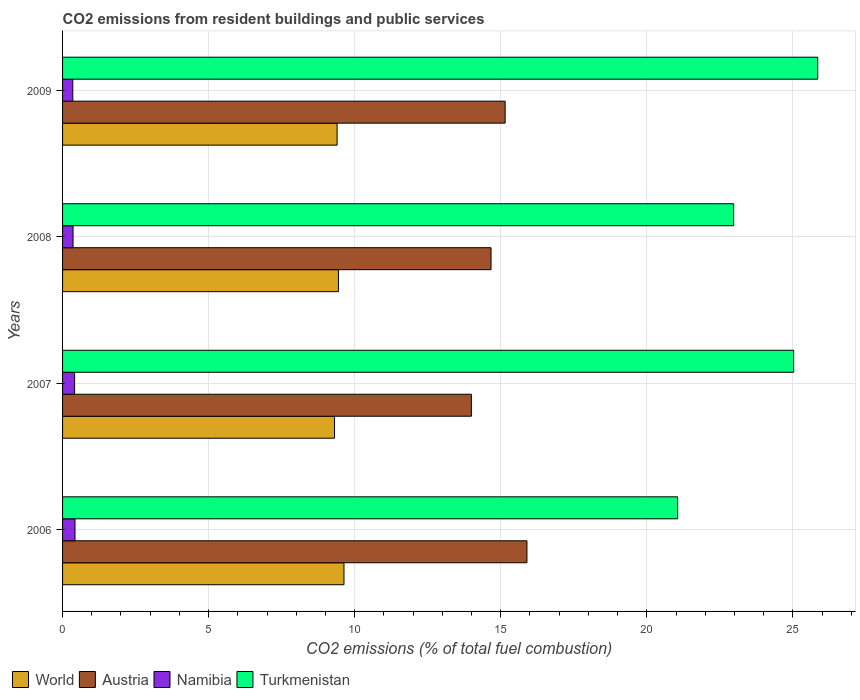How many different coloured bars are there?
Offer a very short reply. 4. How many groups of bars are there?
Your answer should be very brief. 4. Are the number of bars per tick equal to the number of legend labels?
Offer a very short reply. Yes. How many bars are there on the 4th tick from the bottom?
Offer a very short reply. 4. What is the label of the 1st group of bars from the top?
Offer a very short reply. 2009. In how many cases, is the number of bars for a given year not equal to the number of legend labels?
Keep it short and to the point. 0. What is the total CO2 emitted in Namibia in 2008?
Your answer should be very brief. 0.36. Across all years, what is the maximum total CO2 emitted in Turkmenistan?
Provide a succinct answer. 25.85. Across all years, what is the minimum total CO2 emitted in Austria?
Your answer should be very brief. 13.99. In which year was the total CO2 emitted in World minimum?
Offer a very short reply. 2007. What is the total total CO2 emitted in Turkmenistan in the graph?
Offer a very short reply. 94.91. What is the difference between the total CO2 emitted in Austria in 2007 and that in 2009?
Provide a succinct answer. -1.16. What is the difference between the total CO2 emitted in Turkmenistan in 2006 and the total CO2 emitted in Austria in 2009?
Give a very brief answer. 5.9. What is the average total CO2 emitted in Austria per year?
Offer a very short reply. 14.93. In the year 2006, what is the difference between the total CO2 emitted in Turkmenistan and total CO2 emitted in Namibia?
Offer a terse response. 20.63. In how many years, is the total CO2 emitted in World greater than 17 ?
Your answer should be compact. 0. What is the ratio of the total CO2 emitted in World in 2008 to that in 2009?
Make the answer very short. 1. Is the total CO2 emitted in World in 2006 less than that in 2008?
Your answer should be compact. No. Is the difference between the total CO2 emitted in Turkmenistan in 2006 and 2007 greater than the difference between the total CO2 emitted in Namibia in 2006 and 2007?
Your answer should be very brief. No. What is the difference between the highest and the second highest total CO2 emitted in World?
Ensure brevity in your answer.  0.19. What is the difference between the highest and the lowest total CO2 emitted in Namibia?
Keep it short and to the point. 0.08. Is the sum of the total CO2 emitted in Austria in 2006 and 2009 greater than the maximum total CO2 emitted in World across all years?
Provide a succinct answer. Yes. Is it the case that in every year, the sum of the total CO2 emitted in World and total CO2 emitted in Turkmenistan is greater than the sum of total CO2 emitted in Austria and total CO2 emitted in Namibia?
Make the answer very short. Yes. What does the 1st bar from the top in 2009 represents?
Offer a terse response. Turkmenistan. Is it the case that in every year, the sum of the total CO2 emitted in Turkmenistan and total CO2 emitted in Namibia is greater than the total CO2 emitted in World?
Keep it short and to the point. Yes. How many bars are there?
Your response must be concise. 16. Are all the bars in the graph horizontal?
Your answer should be very brief. Yes. How many years are there in the graph?
Your answer should be compact. 4. Does the graph contain any zero values?
Ensure brevity in your answer.  No. Where does the legend appear in the graph?
Your answer should be very brief. Bottom left. How many legend labels are there?
Provide a succinct answer. 4. How are the legend labels stacked?
Give a very brief answer. Horizontal. What is the title of the graph?
Offer a terse response. CO2 emissions from resident buildings and public services. Does "Uruguay" appear as one of the legend labels in the graph?
Make the answer very short. No. What is the label or title of the X-axis?
Ensure brevity in your answer.  CO2 emissions (% of total fuel combustion). What is the CO2 emissions (% of total fuel combustion) in World in 2006?
Your response must be concise. 9.63. What is the CO2 emissions (% of total fuel combustion) in Austria in 2006?
Your response must be concise. 15.9. What is the CO2 emissions (% of total fuel combustion) in Namibia in 2006?
Provide a succinct answer. 0.43. What is the CO2 emissions (% of total fuel combustion) of Turkmenistan in 2006?
Provide a succinct answer. 21.05. What is the CO2 emissions (% of total fuel combustion) in World in 2007?
Make the answer very short. 9.31. What is the CO2 emissions (% of total fuel combustion) in Austria in 2007?
Ensure brevity in your answer.  13.99. What is the CO2 emissions (% of total fuel combustion) in Namibia in 2007?
Your answer should be very brief. 0.41. What is the CO2 emissions (% of total fuel combustion) of Turkmenistan in 2007?
Offer a very short reply. 25.03. What is the CO2 emissions (% of total fuel combustion) of World in 2008?
Offer a very short reply. 9.44. What is the CO2 emissions (% of total fuel combustion) of Austria in 2008?
Provide a succinct answer. 14.67. What is the CO2 emissions (% of total fuel combustion) of Namibia in 2008?
Provide a succinct answer. 0.36. What is the CO2 emissions (% of total fuel combustion) of Turkmenistan in 2008?
Make the answer very short. 22.97. What is the CO2 emissions (% of total fuel combustion) of World in 2009?
Offer a terse response. 9.4. What is the CO2 emissions (% of total fuel combustion) in Austria in 2009?
Ensure brevity in your answer.  15.15. What is the CO2 emissions (% of total fuel combustion) of Namibia in 2009?
Provide a short and direct response. 0.35. What is the CO2 emissions (% of total fuel combustion) in Turkmenistan in 2009?
Your answer should be very brief. 25.85. Across all years, what is the maximum CO2 emissions (% of total fuel combustion) in World?
Provide a succinct answer. 9.63. Across all years, what is the maximum CO2 emissions (% of total fuel combustion) of Austria?
Ensure brevity in your answer.  15.9. Across all years, what is the maximum CO2 emissions (% of total fuel combustion) of Namibia?
Provide a short and direct response. 0.43. Across all years, what is the maximum CO2 emissions (% of total fuel combustion) of Turkmenistan?
Ensure brevity in your answer.  25.85. Across all years, what is the minimum CO2 emissions (% of total fuel combustion) in World?
Keep it short and to the point. 9.31. Across all years, what is the minimum CO2 emissions (% of total fuel combustion) in Austria?
Offer a very short reply. 13.99. Across all years, what is the minimum CO2 emissions (% of total fuel combustion) in Namibia?
Your answer should be compact. 0.35. Across all years, what is the minimum CO2 emissions (% of total fuel combustion) of Turkmenistan?
Keep it short and to the point. 21.05. What is the total CO2 emissions (% of total fuel combustion) of World in the graph?
Your answer should be very brief. 37.78. What is the total CO2 emissions (% of total fuel combustion) of Austria in the graph?
Provide a succinct answer. 59.71. What is the total CO2 emissions (% of total fuel combustion) in Namibia in the graph?
Provide a succinct answer. 1.55. What is the total CO2 emissions (% of total fuel combustion) of Turkmenistan in the graph?
Provide a succinct answer. 94.91. What is the difference between the CO2 emissions (% of total fuel combustion) in World in 2006 and that in 2007?
Offer a terse response. 0.32. What is the difference between the CO2 emissions (% of total fuel combustion) of Austria in 2006 and that in 2007?
Keep it short and to the point. 1.9. What is the difference between the CO2 emissions (% of total fuel combustion) in Namibia in 2006 and that in 2007?
Your response must be concise. 0.01. What is the difference between the CO2 emissions (% of total fuel combustion) in Turkmenistan in 2006 and that in 2007?
Your response must be concise. -3.97. What is the difference between the CO2 emissions (% of total fuel combustion) of World in 2006 and that in 2008?
Provide a short and direct response. 0.19. What is the difference between the CO2 emissions (% of total fuel combustion) of Austria in 2006 and that in 2008?
Give a very brief answer. 1.23. What is the difference between the CO2 emissions (% of total fuel combustion) in Namibia in 2006 and that in 2008?
Your response must be concise. 0.07. What is the difference between the CO2 emissions (% of total fuel combustion) in Turkmenistan in 2006 and that in 2008?
Offer a very short reply. -1.92. What is the difference between the CO2 emissions (% of total fuel combustion) in World in 2006 and that in 2009?
Offer a very short reply. 0.23. What is the difference between the CO2 emissions (% of total fuel combustion) in Austria in 2006 and that in 2009?
Offer a terse response. 0.75. What is the difference between the CO2 emissions (% of total fuel combustion) in Namibia in 2006 and that in 2009?
Keep it short and to the point. 0.08. What is the difference between the CO2 emissions (% of total fuel combustion) in Turkmenistan in 2006 and that in 2009?
Your answer should be very brief. -4.8. What is the difference between the CO2 emissions (% of total fuel combustion) in World in 2007 and that in 2008?
Make the answer very short. -0.13. What is the difference between the CO2 emissions (% of total fuel combustion) in Austria in 2007 and that in 2008?
Offer a very short reply. -0.67. What is the difference between the CO2 emissions (% of total fuel combustion) in Namibia in 2007 and that in 2008?
Ensure brevity in your answer.  0.05. What is the difference between the CO2 emissions (% of total fuel combustion) of Turkmenistan in 2007 and that in 2008?
Your answer should be compact. 2.05. What is the difference between the CO2 emissions (% of total fuel combustion) in World in 2007 and that in 2009?
Ensure brevity in your answer.  -0.09. What is the difference between the CO2 emissions (% of total fuel combustion) in Austria in 2007 and that in 2009?
Give a very brief answer. -1.16. What is the difference between the CO2 emissions (% of total fuel combustion) of Namibia in 2007 and that in 2009?
Provide a short and direct response. 0.06. What is the difference between the CO2 emissions (% of total fuel combustion) of Turkmenistan in 2007 and that in 2009?
Provide a succinct answer. -0.82. What is the difference between the CO2 emissions (% of total fuel combustion) in World in 2008 and that in 2009?
Your response must be concise. 0.05. What is the difference between the CO2 emissions (% of total fuel combustion) in Austria in 2008 and that in 2009?
Your answer should be compact. -0.48. What is the difference between the CO2 emissions (% of total fuel combustion) of Namibia in 2008 and that in 2009?
Offer a very short reply. 0.01. What is the difference between the CO2 emissions (% of total fuel combustion) in Turkmenistan in 2008 and that in 2009?
Provide a short and direct response. -2.88. What is the difference between the CO2 emissions (% of total fuel combustion) in World in 2006 and the CO2 emissions (% of total fuel combustion) in Austria in 2007?
Provide a short and direct response. -4.36. What is the difference between the CO2 emissions (% of total fuel combustion) in World in 2006 and the CO2 emissions (% of total fuel combustion) in Namibia in 2007?
Offer a terse response. 9.22. What is the difference between the CO2 emissions (% of total fuel combustion) in World in 2006 and the CO2 emissions (% of total fuel combustion) in Turkmenistan in 2007?
Your answer should be compact. -15.39. What is the difference between the CO2 emissions (% of total fuel combustion) in Austria in 2006 and the CO2 emissions (% of total fuel combustion) in Namibia in 2007?
Make the answer very short. 15.48. What is the difference between the CO2 emissions (% of total fuel combustion) in Austria in 2006 and the CO2 emissions (% of total fuel combustion) in Turkmenistan in 2007?
Provide a succinct answer. -9.13. What is the difference between the CO2 emissions (% of total fuel combustion) of Namibia in 2006 and the CO2 emissions (% of total fuel combustion) of Turkmenistan in 2007?
Keep it short and to the point. -24.6. What is the difference between the CO2 emissions (% of total fuel combustion) in World in 2006 and the CO2 emissions (% of total fuel combustion) in Austria in 2008?
Offer a terse response. -5.03. What is the difference between the CO2 emissions (% of total fuel combustion) of World in 2006 and the CO2 emissions (% of total fuel combustion) of Namibia in 2008?
Offer a terse response. 9.27. What is the difference between the CO2 emissions (% of total fuel combustion) in World in 2006 and the CO2 emissions (% of total fuel combustion) in Turkmenistan in 2008?
Your answer should be compact. -13.34. What is the difference between the CO2 emissions (% of total fuel combustion) of Austria in 2006 and the CO2 emissions (% of total fuel combustion) of Namibia in 2008?
Give a very brief answer. 15.54. What is the difference between the CO2 emissions (% of total fuel combustion) in Austria in 2006 and the CO2 emissions (% of total fuel combustion) in Turkmenistan in 2008?
Your answer should be compact. -7.08. What is the difference between the CO2 emissions (% of total fuel combustion) of Namibia in 2006 and the CO2 emissions (% of total fuel combustion) of Turkmenistan in 2008?
Offer a terse response. -22.55. What is the difference between the CO2 emissions (% of total fuel combustion) of World in 2006 and the CO2 emissions (% of total fuel combustion) of Austria in 2009?
Keep it short and to the point. -5.52. What is the difference between the CO2 emissions (% of total fuel combustion) in World in 2006 and the CO2 emissions (% of total fuel combustion) in Namibia in 2009?
Your answer should be compact. 9.28. What is the difference between the CO2 emissions (% of total fuel combustion) in World in 2006 and the CO2 emissions (% of total fuel combustion) in Turkmenistan in 2009?
Offer a terse response. -16.22. What is the difference between the CO2 emissions (% of total fuel combustion) in Austria in 2006 and the CO2 emissions (% of total fuel combustion) in Namibia in 2009?
Provide a short and direct response. 15.55. What is the difference between the CO2 emissions (% of total fuel combustion) of Austria in 2006 and the CO2 emissions (% of total fuel combustion) of Turkmenistan in 2009?
Your answer should be very brief. -9.95. What is the difference between the CO2 emissions (% of total fuel combustion) of Namibia in 2006 and the CO2 emissions (% of total fuel combustion) of Turkmenistan in 2009?
Keep it short and to the point. -25.43. What is the difference between the CO2 emissions (% of total fuel combustion) of World in 2007 and the CO2 emissions (% of total fuel combustion) of Austria in 2008?
Offer a terse response. -5.36. What is the difference between the CO2 emissions (% of total fuel combustion) in World in 2007 and the CO2 emissions (% of total fuel combustion) in Namibia in 2008?
Provide a short and direct response. 8.95. What is the difference between the CO2 emissions (% of total fuel combustion) of World in 2007 and the CO2 emissions (% of total fuel combustion) of Turkmenistan in 2008?
Make the answer very short. -13.66. What is the difference between the CO2 emissions (% of total fuel combustion) of Austria in 2007 and the CO2 emissions (% of total fuel combustion) of Namibia in 2008?
Offer a very short reply. 13.64. What is the difference between the CO2 emissions (% of total fuel combustion) of Austria in 2007 and the CO2 emissions (% of total fuel combustion) of Turkmenistan in 2008?
Ensure brevity in your answer.  -8.98. What is the difference between the CO2 emissions (% of total fuel combustion) of Namibia in 2007 and the CO2 emissions (% of total fuel combustion) of Turkmenistan in 2008?
Your response must be concise. -22.56. What is the difference between the CO2 emissions (% of total fuel combustion) in World in 2007 and the CO2 emissions (% of total fuel combustion) in Austria in 2009?
Ensure brevity in your answer.  -5.84. What is the difference between the CO2 emissions (% of total fuel combustion) in World in 2007 and the CO2 emissions (% of total fuel combustion) in Namibia in 2009?
Your response must be concise. 8.96. What is the difference between the CO2 emissions (% of total fuel combustion) in World in 2007 and the CO2 emissions (% of total fuel combustion) in Turkmenistan in 2009?
Give a very brief answer. -16.54. What is the difference between the CO2 emissions (% of total fuel combustion) in Austria in 2007 and the CO2 emissions (% of total fuel combustion) in Namibia in 2009?
Keep it short and to the point. 13.64. What is the difference between the CO2 emissions (% of total fuel combustion) in Austria in 2007 and the CO2 emissions (% of total fuel combustion) in Turkmenistan in 2009?
Provide a short and direct response. -11.86. What is the difference between the CO2 emissions (% of total fuel combustion) of Namibia in 2007 and the CO2 emissions (% of total fuel combustion) of Turkmenistan in 2009?
Give a very brief answer. -25.44. What is the difference between the CO2 emissions (% of total fuel combustion) in World in 2008 and the CO2 emissions (% of total fuel combustion) in Austria in 2009?
Keep it short and to the point. -5.71. What is the difference between the CO2 emissions (% of total fuel combustion) of World in 2008 and the CO2 emissions (% of total fuel combustion) of Namibia in 2009?
Your response must be concise. 9.09. What is the difference between the CO2 emissions (% of total fuel combustion) in World in 2008 and the CO2 emissions (% of total fuel combustion) in Turkmenistan in 2009?
Your answer should be very brief. -16.41. What is the difference between the CO2 emissions (% of total fuel combustion) in Austria in 2008 and the CO2 emissions (% of total fuel combustion) in Namibia in 2009?
Ensure brevity in your answer.  14.32. What is the difference between the CO2 emissions (% of total fuel combustion) of Austria in 2008 and the CO2 emissions (% of total fuel combustion) of Turkmenistan in 2009?
Your response must be concise. -11.18. What is the difference between the CO2 emissions (% of total fuel combustion) of Namibia in 2008 and the CO2 emissions (% of total fuel combustion) of Turkmenistan in 2009?
Offer a very short reply. -25.49. What is the average CO2 emissions (% of total fuel combustion) of World per year?
Your answer should be very brief. 9.45. What is the average CO2 emissions (% of total fuel combustion) in Austria per year?
Your answer should be compact. 14.93. What is the average CO2 emissions (% of total fuel combustion) in Namibia per year?
Give a very brief answer. 0.39. What is the average CO2 emissions (% of total fuel combustion) in Turkmenistan per year?
Your response must be concise. 23.73. In the year 2006, what is the difference between the CO2 emissions (% of total fuel combustion) of World and CO2 emissions (% of total fuel combustion) of Austria?
Give a very brief answer. -6.26. In the year 2006, what is the difference between the CO2 emissions (% of total fuel combustion) of World and CO2 emissions (% of total fuel combustion) of Namibia?
Your answer should be very brief. 9.21. In the year 2006, what is the difference between the CO2 emissions (% of total fuel combustion) in World and CO2 emissions (% of total fuel combustion) in Turkmenistan?
Provide a short and direct response. -11.42. In the year 2006, what is the difference between the CO2 emissions (% of total fuel combustion) in Austria and CO2 emissions (% of total fuel combustion) in Namibia?
Offer a terse response. 15.47. In the year 2006, what is the difference between the CO2 emissions (% of total fuel combustion) in Austria and CO2 emissions (% of total fuel combustion) in Turkmenistan?
Keep it short and to the point. -5.16. In the year 2006, what is the difference between the CO2 emissions (% of total fuel combustion) of Namibia and CO2 emissions (% of total fuel combustion) of Turkmenistan?
Provide a short and direct response. -20.63. In the year 2007, what is the difference between the CO2 emissions (% of total fuel combustion) in World and CO2 emissions (% of total fuel combustion) in Austria?
Your answer should be compact. -4.68. In the year 2007, what is the difference between the CO2 emissions (% of total fuel combustion) in World and CO2 emissions (% of total fuel combustion) in Namibia?
Ensure brevity in your answer.  8.9. In the year 2007, what is the difference between the CO2 emissions (% of total fuel combustion) in World and CO2 emissions (% of total fuel combustion) in Turkmenistan?
Provide a short and direct response. -15.72. In the year 2007, what is the difference between the CO2 emissions (% of total fuel combustion) in Austria and CO2 emissions (% of total fuel combustion) in Namibia?
Provide a succinct answer. 13.58. In the year 2007, what is the difference between the CO2 emissions (% of total fuel combustion) of Austria and CO2 emissions (% of total fuel combustion) of Turkmenistan?
Give a very brief answer. -11.03. In the year 2007, what is the difference between the CO2 emissions (% of total fuel combustion) in Namibia and CO2 emissions (% of total fuel combustion) in Turkmenistan?
Offer a very short reply. -24.62. In the year 2008, what is the difference between the CO2 emissions (% of total fuel combustion) of World and CO2 emissions (% of total fuel combustion) of Austria?
Keep it short and to the point. -5.22. In the year 2008, what is the difference between the CO2 emissions (% of total fuel combustion) in World and CO2 emissions (% of total fuel combustion) in Namibia?
Make the answer very short. 9.08. In the year 2008, what is the difference between the CO2 emissions (% of total fuel combustion) in World and CO2 emissions (% of total fuel combustion) in Turkmenistan?
Your answer should be very brief. -13.53. In the year 2008, what is the difference between the CO2 emissions (% of total fuel combustion) in Austria and CO2 emissions (% of total fuel combustion) in Namibia?
Provide a succinct answer. 14.31. In the year 2008, what is the difference between the CO2 emissions (% of total fuel combustion) in Austria and CO2 emissions (% of total fuel combustion) in Turkmenistan?
Provide a short and direct response. -8.31. In the year 2008, what is the difference between the CO2 emissions (% of total fuel combustion) in Namibia and CO2 emissions (% of total fuel combustion) in Turkmenistan?
Keep it short and to the point. -22.61. In the year 2009, what is the difference between the CO2 emissions (% of total fuel combustion) in World and CO2 emissions (% of total fuel combustion) in Austria?
Ensure brevity in your answer.  -5.75. In the year 2009, what is the difference between the CO2 emissions (% of total fuel combustion) in World and CO2 emissions (% of total fuel combustion) in Namibia?
Your answer should be compact. 9.05. In the year 2009, what is the difference between the CO2 emissions (% of total fuel combustion) in World and CO2 emissions (% of total fuel combustion) in Turkmenistan?
Give a very brief answer. -16.45. In the year 2009, what is the difference between the CO2 emissions (% of total fuel combustion) in Austria and CO2 emissions (% of total fuel combustion) in Namibia?
Offer a terse response. 14.8. In the year 2009, what is the difference between the CO2 emissions (% of total fuel combustion) in Austria and CO2 emissions (% of total fuel combustion) in Turkmenistan?
Offer a terse response. -10.7. In the year 2009, what is the difference between the CO2 emissions (% of total fuel combustion) of Namibia and CO2 emissions (% of total fuel combustion) of Turkmenistan?
Keep it short and to the point. -25.5. What is the ratio of the CO2 emissions (% of total fuel combustion) of World in 2006 to that in 2007?
Provide a short and direct response. 1.03. What is the ratio of the CO2 emissions (% of total fuel combustion) of Austria in 2006 to that in 2007?
Offer a terse response. 1.14. What is the ratio of the CO2 emissions (% of total fuel combustion) in Namibia in 2006 to that in 2007?
Give a very brief answer. 1.03. What is the ratio of the CO2 emissions (% of total fuel combustion) in Turkmenistan in 2006 to that in 2007?
Your answer should be very brief. 0.84. What is the ratio of the CO2 emissions (% of total fuel combustion) in World in 2006 to that in 2008?
Offer a very short reply. 1.02. What is the ratio of the CO2 emissions (% of total fuel combustion) in Austria in 2006 to that in 2008?
Your answer should be very brief. 1.08. What is the ratio of the CO2 emissions (% of total fuel combustion) of Namibia in 2006 to that in 2008?
Ensure brevity in your answer.  1.19. What is the ratio of the CO2 emissions (% of total fuel combustion) of Turkmenistan in 2006 to that in 2008?
Offer a very short reply. 0.92. What is the ratio of the CO2 emissions (% of total fuel combustion) in Austria in 2006 to that in 2009?
Offer a very short reply. 1.05. What is the ratio of the CO2 emissions (% of total fuel combustion) of Namibia in 2006 to that in 2009?
Provide a succinct answer. 1.22. What is the ratio of the CO2 emissions (% of total fuel combustion) in Turkmenistan in 2006 to that in 2009?
Make the answer very short. 0.81. What is the ratio of the CO2 emissions (% of total fuel combustion) in World in 2007 to that in 2008?
Provide a short and direct response. 0.99. What is the ratio of the CO2 emissions (% of total fuel combustion) of Austria in 2007 to that in 2008?
Give a very brief answer. 0.95. What is the ratio of the CO2 emissions (% of total fuel combustion) in Namibia in 2007 to that in 2008?
Your answer should be compact. 1.15. What is the ratio of the CO2 emissions (% of total fuel combustion) of Turkmenistan in 2007 to that in 2008?
Keep it short and to the point. 1.09. What is the ratio of the CO2 emissions (% of total fuel combustion) in World in 2007 to that in 2009?
Your answer should be very brief. 0.99. What is the ratio of the CO2 emissions (% of total fuel combustion) of Austria in 2007 to that in 2009?
Offer a very short reply. 0.92. What is the ratio of the CO2 emissions (% of total fuel combustion) in Namibia in 2007 to that in 2009?
Your answer should be compact. 1.18. What is the ratio of the CO2 emissions (% of total fuel combustion) in Turkmenistan in 2007 to that in 2009?
Keep it short and to the point. 0.97. What is the ratio of the CO2 emissions (% of total fuel combustion) of Austria in 2008 to that in 2009?
Your response must be concise. 0.97. What is the ratio of the CO2 emissions (% of total fuel combustion) in Namibia in 2008 to that in 2009?
Your answer should be very brief. 1.03. What is the ratio of the CO2 emissions (% of total fuel combustion) of Turkmenistan in 2008 to that in 2009?
Your answer should be very brief. 0.89. What is the difference between the highest and the second highest CO2 emissions (% of total fuel combustion) of World?
Keep it short and to the point. 0.19. What is the difference between the highest and the second highest CO2 emissions (% of total fuel combustion) of Austria?
Give a very brief answer. 0.75. What is the difference between the highest and the second highest CO2 emissions (% of total fuel combustion) in Namibia?
Offer a very short reply. 0.01. What is the difference between the highest and the second highest CO2 emissions (% of total fuel combustion) in Turkmenistan?
Make the answer very short. 0.82. What is the difference between the highest and the lowest CO2 emissions (% of total fuel combustion) of World?
Ensure brevity in your answer.  0.32. What is the difference between the highest and the lowest CO2 emissions (% of total fuel combustion) in Austria?
Keep it short and to the point. 1.9. What is the difference between the highest and the lowest CO2 emissions (% of total fuel combustion) of Namibia?
Your response must be concise. 0.08. What is the difference between the highest and the lowest CO2 emissions (% of total fuel combustion) in Turkmenistan?
Provide a short and direct response. 4.8. 